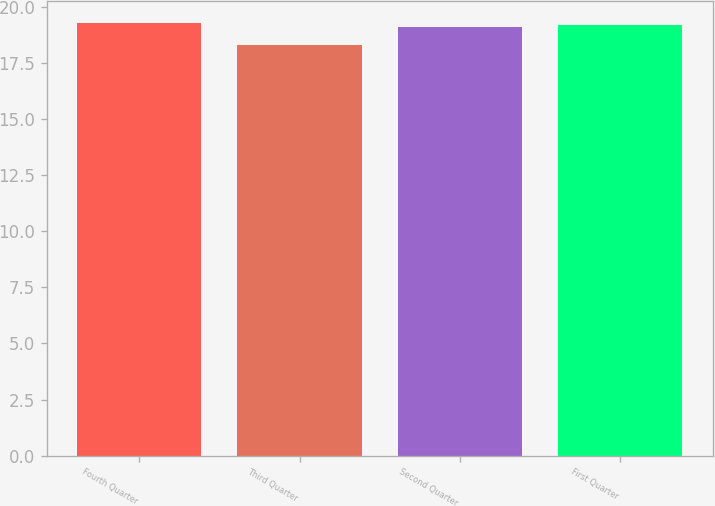Convert chart to OTSL. <chart><loc_0><loc_0><loc_500><loc_500><bar_chart><fcel>Fourth Quarter<fcel>Third Quarter<fcel>Second Quarter<fcel>First Quarter<nl><fcel>19.28<fcel>18.27<fcel>19.1<fcel>19.19<nl></chart> 